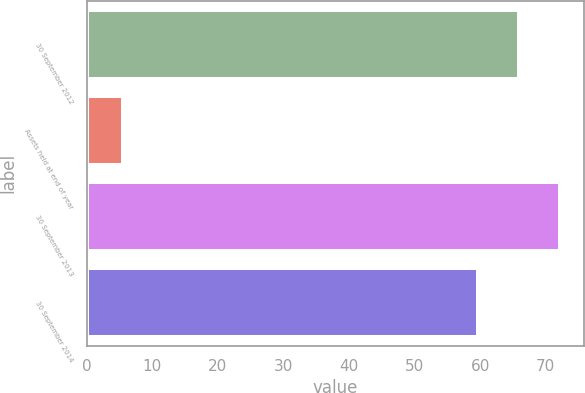<chart> <loc_0><loc_0><loc_500><loc_500><bar_chart><fcel>30 September 2012<fcel>Assets held at end of year<fcel>30 September 2013<fcel>30 September 2014<nl><fcel>65.97<fcel>5.6<fcel>72.24<fcel>59.7<nl></chart> 